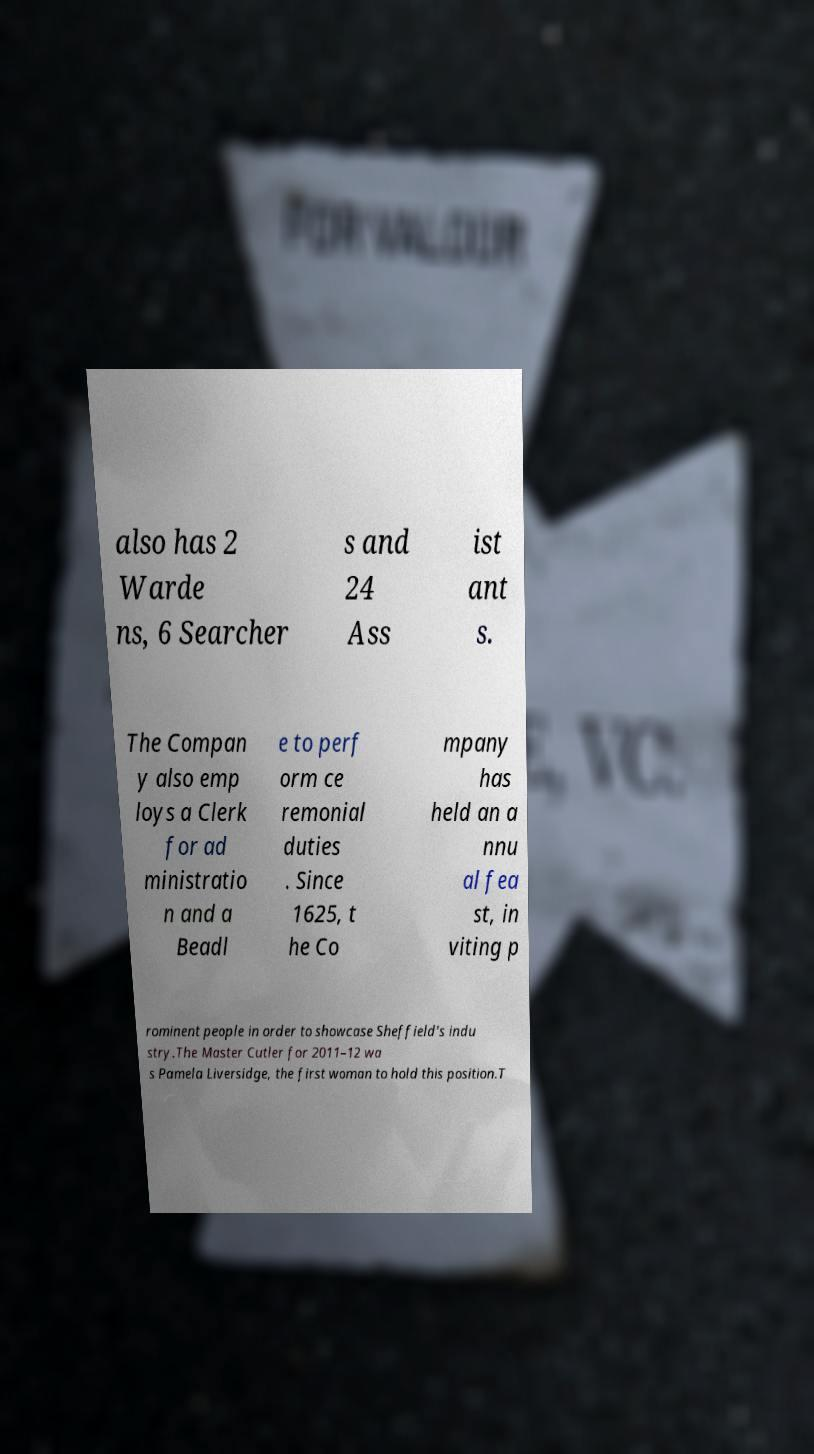Can you accurately transcribe the text from the provided image for me? also has 2 Warde ns, 6 Searcher s and 24 Ass ist ant s. The Compan y also emp loys a Clerk for ad ministratio n and a Beadl e to perf orm ce remonial duties . Since 1625, t he Co mpany has held an a nnu al fea st, in viting p rominent people in order to showcase Sheffield's indu stry.The Master Cutler for 2011–12 wa s Pamela Liversidge, the first woman to hold this position.T 